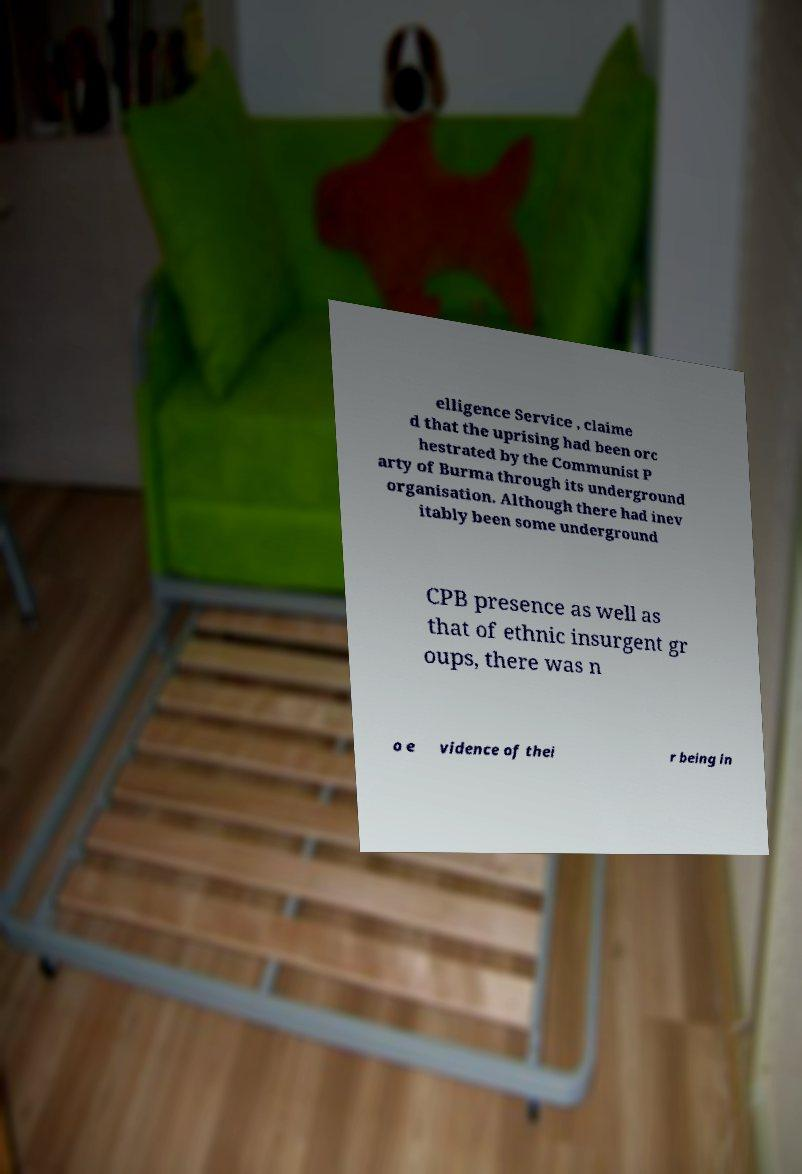For documentation purposes, I need the text within this image transcribed. Could you provide that? elligence Service , claime d that the uprising had been orc hestrated by the Communist P arty of Burma through its underground organisation. Although there had inev itably been some underground CPB presence as well as that of ethnic insurgent gr oups, there was n o e vidence of thei r being in 